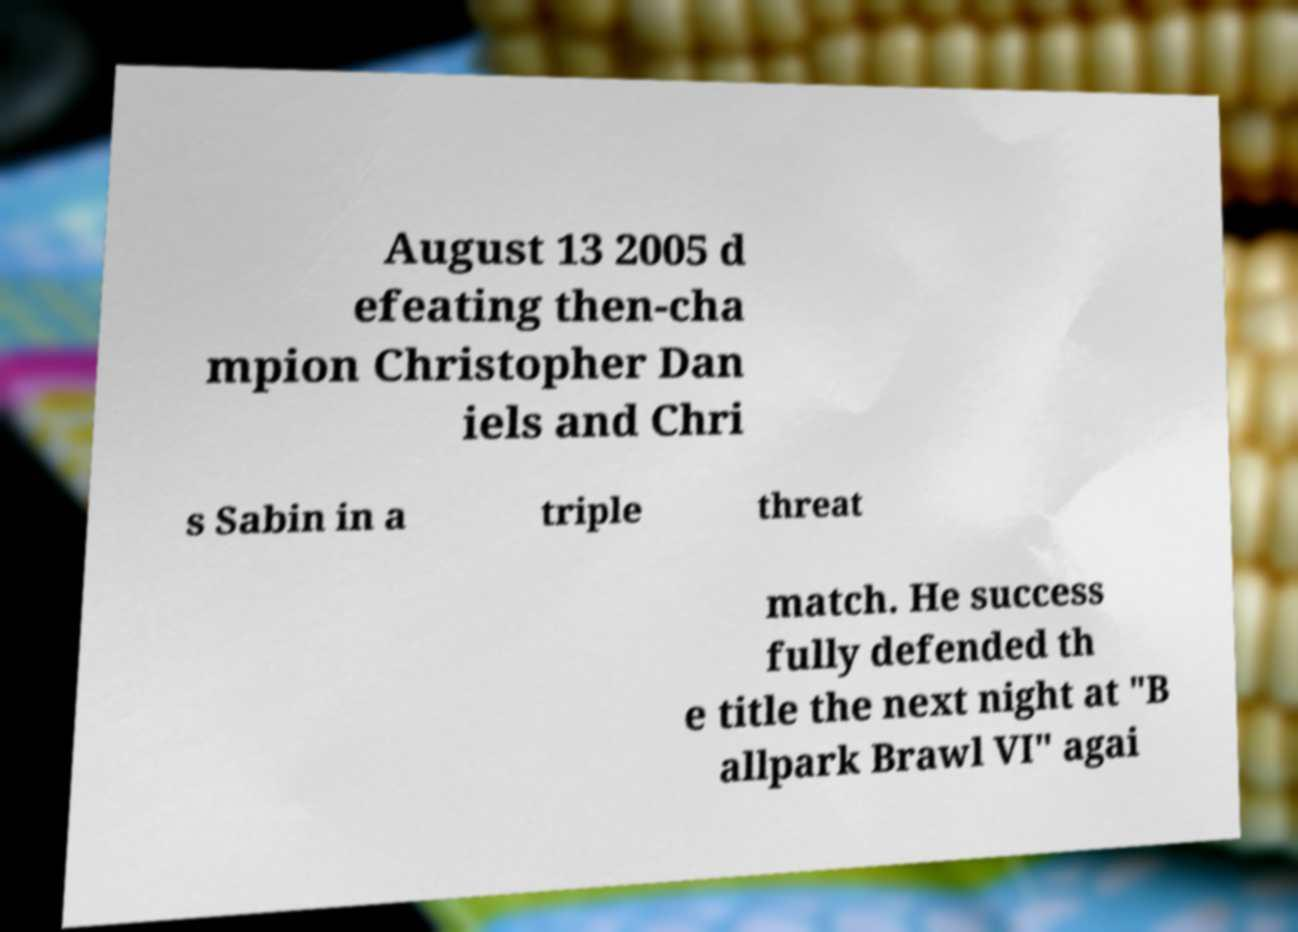Please identify and transcribe the text found in this image. August 13 2005 d efeating then-cha mpion Christopher Dan iels and Chri s Sabin in a triple threat match. He success fully defended th e title the next night at "B allpark Brawl VI" agai 